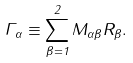<formula> <loc_0><loc_0><loc_500><loc_500>\Gamma _ { \alpha } \equiv \sum _ { \beta = 1 } ^ { 2 } M _ { \alpha \beta } R _ { \beta } .</formula> 